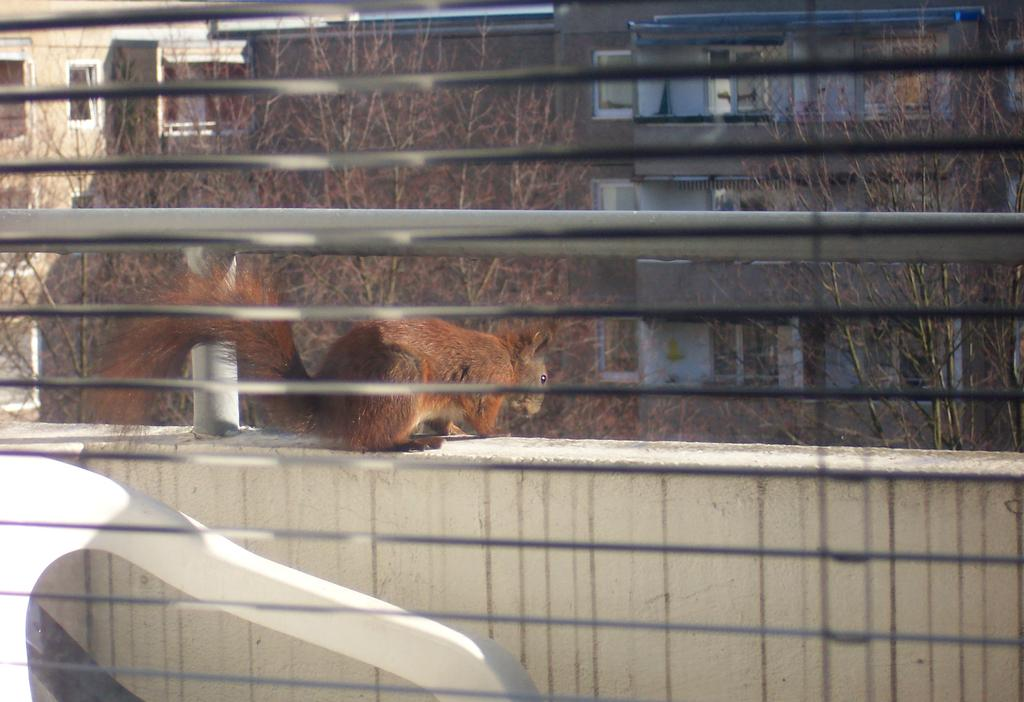What animal can be seen on the wall in the image? There is a squirrel on the wall in the image. What type of natural environment is visible in the background of the image? There is a group of trees in the background of the image. What type of man-made structures can be seen in the background of the image? There are buildings in the background of the image. What type of barrier is present in the background of the image? There is an iron railing in the background of the image. What type of hope can be seen in the image? There is no hope present in the image; it is a visual representation of a squirrel on a wall and the surrounding environment. 